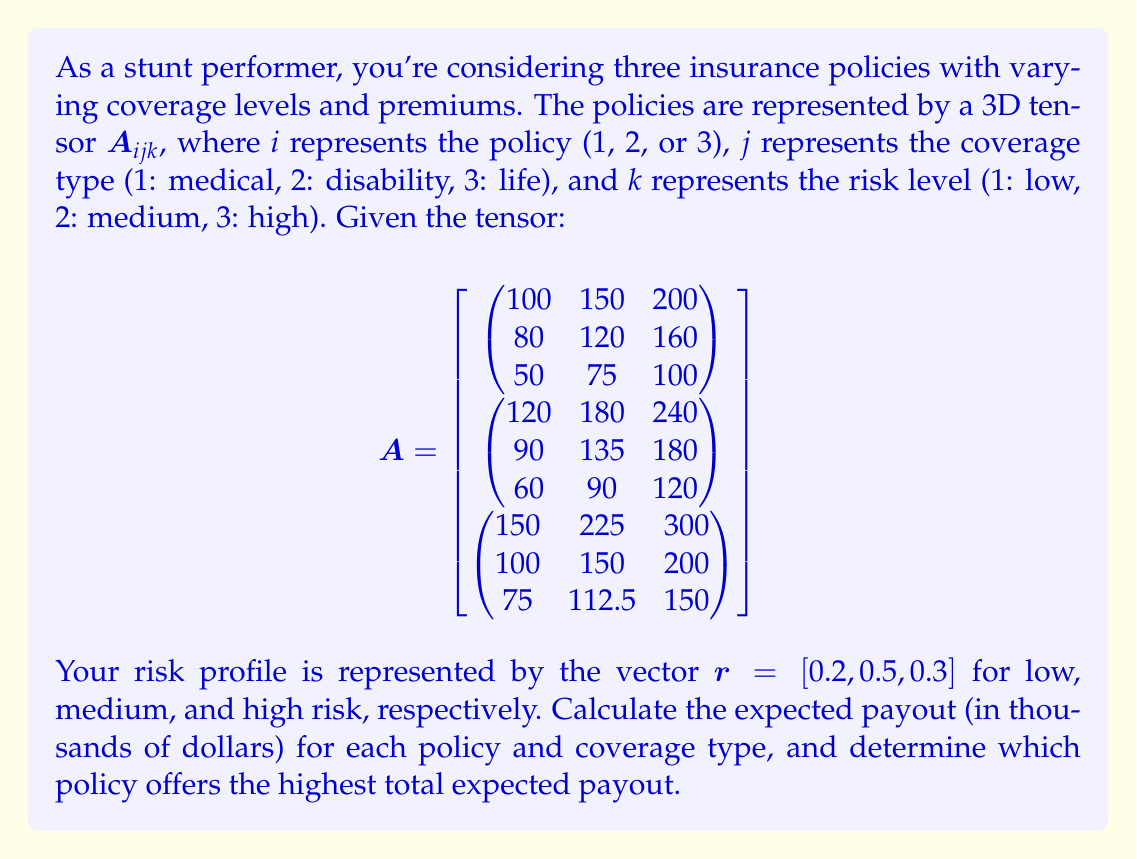Solve this math problem. To solve this problem, we need to follow these steps:

1) First, we need to calculate the expected payout for each policy and coverage type. This is done by multiplying the tensor $A$ with the risk profile vector $r$.

2) Mathematically, this operation can be represented as:

   $$B_{ij} = \sum_{k=1}^3 A_{ijk} \cdot r_k$$

3) Let's calculate this for each policy and coverage type:

   For Policy 1:
   Medical: $100 \cdot 0.2 + 150 \cdot 0.5 + 200 \cdot 0.3 = 160$
   Disability: $80 \cdot 0.2 + 120 \cdot 0.5 + 160 \cdot 0.3 = 124$
   Life: $50 \cdot 0.2 + 75 \cdot 0.5 + 100 \cdot 0.3 = 77.5$

   For Policy 2:
   Medical: $120 \cdot 0.2 + 180 \cdot 0.5 + 240 \cdot 0.3 = 192$
   Disability: $90 \cdot 0.2 + 135 \cdot 0.5 + 180 \cdot 0.3 = 139.5$
   Life: $60 \cdot 0.2 + 90 \cdot 0.5 + 120 \cdot 0.3 = 93$

   For Policy 3:
   Medical: $150 \cdot 0.2 + 225 \cdot 0.5 + 300 \cdot 0.3 = 240$
   Disability: $100 \cdot 0.2 + 150 \cdot 0.5 + 200 \cdot 0.3 = 155$
   Life: $75 \cdot 0.2 + 112.5 \cdot 0.5 + 150 \cdot 0.3 = 116.25$

4) Now we have the expected payout matrix $B$:

   $$B = \begin{pmatrix}
   160 & 124 & 77.5 \\
   192 & 139.5 & 93 \\
   240 & 155 & 116.25
   \end{pmatrix}$$

5) To find the total expected payout for each policy, we sum across the rows:

   Policy 1: $160 + 124 + 77.5 = 361.5$
   Policy 2: $192 + 139.5 + 93 = 424.5$
   Policy 3: $240 + 155 + 116.25 = 511.25$

6) The policy with the highest total expected payout is Policy 3 with $511.25 thousand.
Answer: Policy 3, with an expected payout of $511,250 